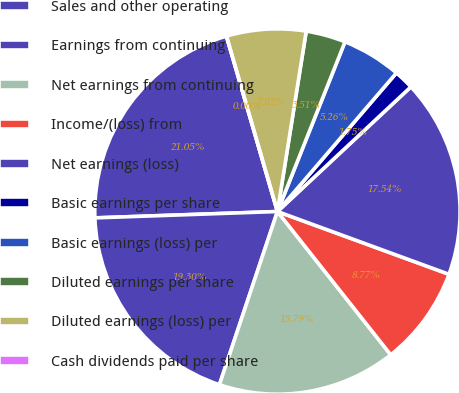Convert chart. <chart><loc_0><loc_0><loc_500><loc_500><pie_chart><fcel>Sales and other operating<fcel>Earnings from continuing<fcel>Net earnings from continuing<fcel>Income/(loss) from<fcel>Net earnings (loss)<fcel>Basic earnings per share<fcel>Basic earnings (loss) per<fcel>Diluted earnings per share<fcel>Diluted earnings (loss) per<fcel>Cash dividends paid per share<nl><fcel>21.05%<fcel>19.3%<fcel>15.79%<fcel>8.77%<fcel>17.54%<fcel>1.75%<fcel>5.26%<fcel>3.51%<fcel>7.02%<fcel>0.0%<nl></chart> 